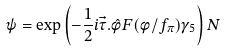Convert formula to latex. <formula><loc_0><loc_0><loc_500><loc_500>\psi = \exp \left ( - \frac { 1 } { 2 } i \vec { \tau } . \hat { \phi } F ( \phi / f _ { \pi } ) \gamma _ { 5 } \right ) N</formula> 